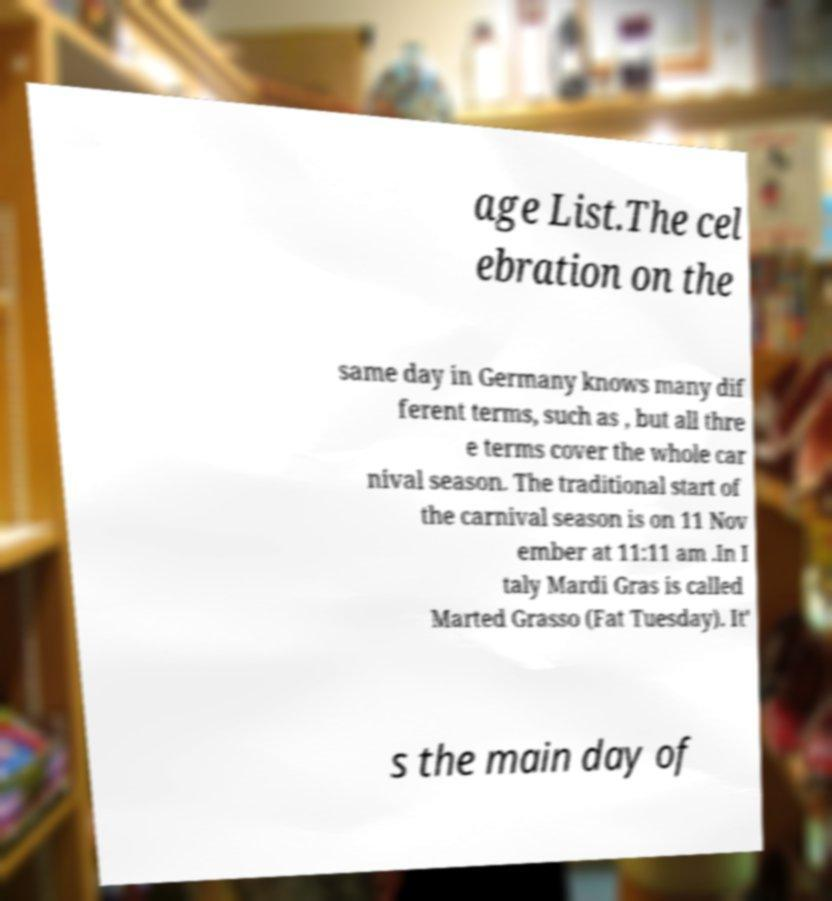What messages or text are displayed in this image? I need them in a readable, typed format. age List.The cel ebration on the same day in Germany knows many dif ferent terms, such as , but all thre e terms cover the whole car nival season. The traditional start of the carnival season is on 11 Nov ember at 11:11 am .In I taly Mardi Gras is called Marted Grasso (Fat Tuesday). It' s the main day of 